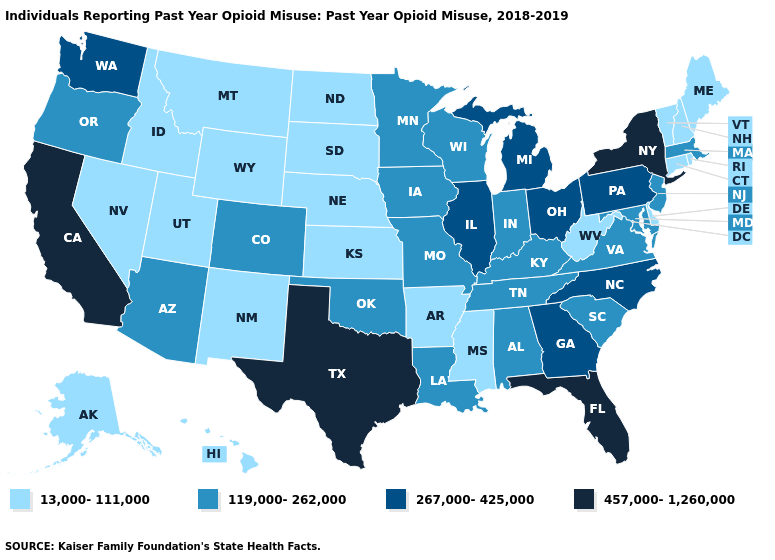Among the states that border Rhode Island , which have the lowest value?
Short answer required. Connecticut. Does Rhode Island have the same value as Oklahoma?
Give a very brief answer. No. What is the highest value in the South ?
Quick response, please. 457,000-1,260,000. What is the value of Tennessee?
Be succinct. 119,000-262,000. Which states have the highest value in the USA?
Keep it brief. California, Florida, New York, Texas. What is the value of Delaware?
Be succinct. 13,000-111,000. Which states have the lowest value in the USA?
Give a very brief answer. Alaska, Arkansas, Connecticut, Delaware, Hawaii, Idaho, Kansas, Maine, Mississippi, Montana, Nebraska, Nevada, New Hampshire, New Mexico, North Dakota, Rhode Island, South Dakota, Utah, Vermont, West Virginia, Wyoming. Name the states that have a value in the range 13,000-111,000?
Be succinct. Alaska, Arkansas, Connecticut, Delaware, Hawaii, Idaho, Kansas, Maine, Mississippi, Montana, Nebraska, Nevada, New Hampshire, New Mexico, North Dakota, Rhode Island, South Dakota, Utah, Vermont, West Virginia, Wyoming. Which states have the lowest value in the Northeast?
Short answer required. Connecticut, Maine, New Hampshire, Rhode Island, Vermont. Name the states that have a value in the range 119,000-262,000?
Quick response, please. Alabama, Arizona, Colorado, Indiana, Iowa, Kentucky, Louisiana, Maryland, Massachusetts, Minnesota, Missouri, New Jersey, Oklahoma, Oregon, South Carolina, Tennessee, Virginia, Wisconsin. Name the states that have a value in the range 119,000-262,000?
Keep it brief. Alabama, Arizona, Colorado, Indiana, Iowa, Kentucky, Louisiana, Maryland, Massachusetts, Minnesota, Missouri, New Jersey, Oklahoma, Oregon, South Carolina, Tennessee, Virginia, Wisconsin. Is the legend a continuous bar?
Concise answer only. No. What is the highest value in the USA?
Short answer required. 457,000-1,260,000. 